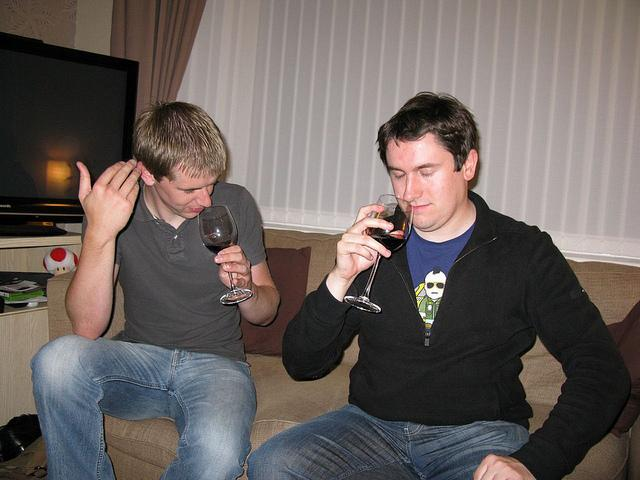Who manufactures the game that the stuffed animal is inspired by?

Choices:
A) sega
B) atari
C) microsoft
D) nintendo nintendo 